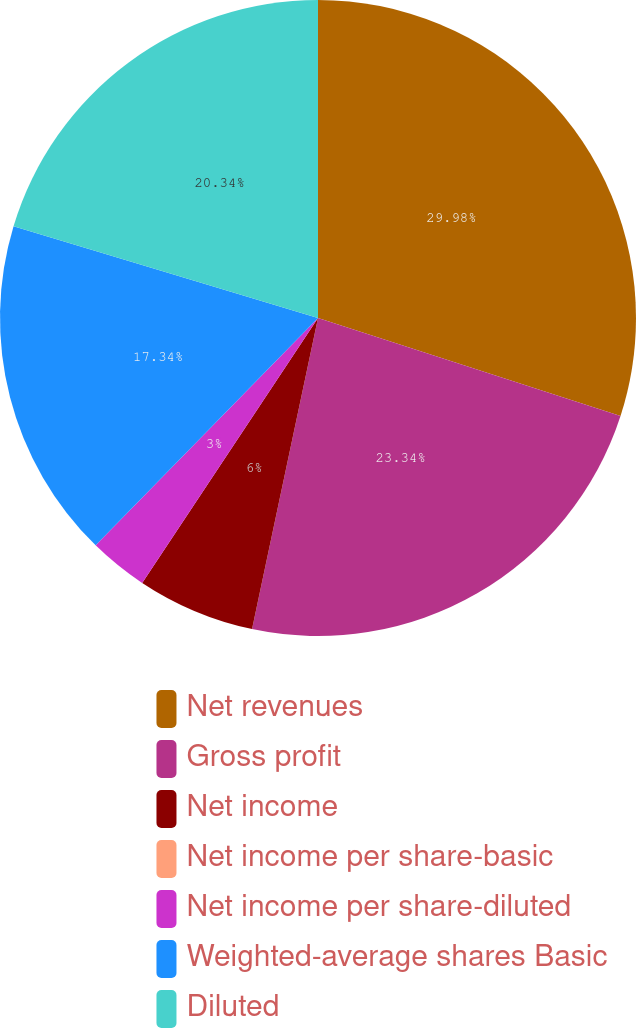Convert chart. <chart><loc_0><loc_0><loc_500><loc_500><pie_chart><fcel>Net revenues<fcel>Gross profit<fcel>Net income<fcel>Net income per share-basic<fcel>Net income per share-diluted<fcel>Weighted-average shares Basic<fcel>Diluted<nl><fcel>29.99%<fcel>23.34%<fcel>6.0%<fcel>0.0%<fcel>3.0%<fcel>17.34%<fcel>20.34%<nl></chart> 